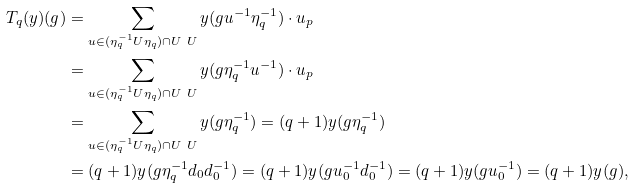Convert formula to latex. <formula><loc_0><loc_0><loc_500><loc_500>T _ { q } ( y ) ( g ) & = \sum _ { u \in ( \eta _ { q } ^ { - 1 } U \eta _ { q } ) \cap U \ U } y ( g u ^ { - 1 } \eta _ { q } ^ { - 1 } ) \cdot u _ { p } \\ & = \sum _ { u \in ( \eta _ { q } ^ { - 1 } U \eta _ { q } ) \cap U \ U } y ( g \eta _ { q } ^ { - 1 } u ^ { - 1 } ) \cdot u _ { p } \\ & = \sum _ { u \in ( \eta _ { q } ^ { - 1 } U \eta _ { q } ) \cap U \ U } y ( g \eta _ { q } ^ { - 1 } ) = ( q + 1 ) y ( g \eta _ { q } ^ { - 1 } ) \\ & = ( q + 1 ) y ( g \eta _ { q } ^ { - 1 } d _ { 0 } d _ { 0 } ^ { - 1 } ) = ( q + 1 ) y ( g u _ { 0 } ^ { - 1 } d _ { 0 } ^ { - 1 } ) = ( q + 1 ) y ( g u _ { 0 } ^ { - 1 } ) = ( q + 1 ) y ( g ) ,</formula> 